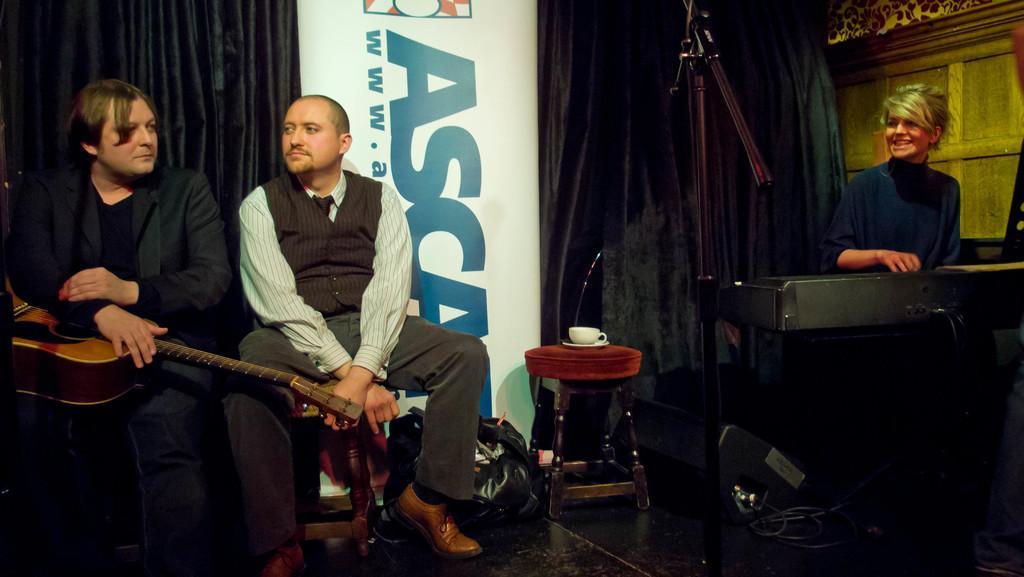Describe this image in one or two sentences. In this picture we can see three persons sitting on the chairs. This is floor and he is holding a guitar with his hands. On the background there is a curtain. And this is the hoarding. 